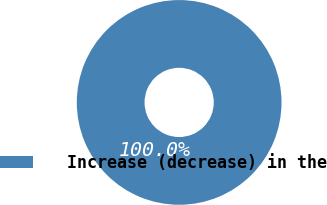Convert chart. <chart><loc_0><loc_0><loc_500><loc_500><pie_chart><fcel>Increase (decrease) in the<nl><fcel>100.0%<nl></chart> 